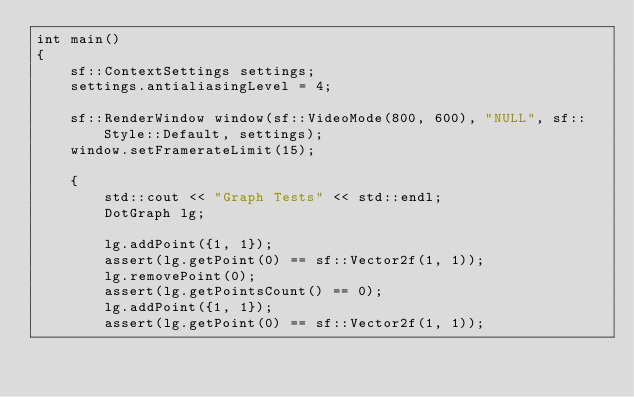<code> <loc_0><loc_0><loc_500><loc_500><_C++_>int main()
{
	sf::ContextSettings settings;
	settings.antialiasingLevel = 4;

	sf::RenderWindow window(sf::VideoMode(800, 600), "NULL", sf::Style::Default, settings);
	window.setFramerateLimit(15);

	{
		std::cout << "Graph Tests" << std::endl;
		DotGraph lg;

		lg.addPoint({1, 1});
		assert(lg.getPoint(0) == sf::Vector2f(1, 1));
		lg.removePoint(0);
		assert(lg.getPointsCount() == 0);
		lg.addPoint({1, 1});
		assert(lg.getPoint(0) == sf::Vector2f(1, 1));</code> 